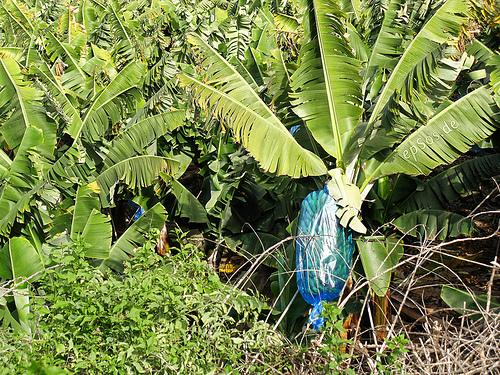Briefly mention the main elements found in the image. A blue bag with bananas, green leaves, brown tree trunks, and various undergrowth are present in the image. Mention the prominent object along with its color and location in the image. There is a blue bag filled with bananas hanging on a tree amidst green leaves and brown tree trunks. Describe the image with a focus on its environment. In a tropical jungle setting with vibrant green vegetation, a blue bag full of bananas can be seen hanging from a tree. Mention the different colors and elements found in the image. The image features green leaves, blue bags, brown tree trunks, and yellow spots, along with areas of undergrowth. Describe the overall setting of the image along with the primary object. The image displays a lush green jungle setting with a blue bag containing bananas hanging from a tree. Using descriptive language, paint a picture of the image. Amidst the verdant foliage and towering brown trunks, a cerulean bag bursting with bananas adorns the tree's broad branches. Provide a simple summary of what can be seen in the image. A blue bag with bananas is hanging on a tree among green leaves and brown tree trunks. What is the overarching atmosphere of the photo? The image exudes a tropical atmosphere, displaying a blue bag filled with bananas amid lush green foliage and trees. Provide a concise description of the most prominent features in the image. A blue bag hangs from a tree filled with bananas, surrounded by vibrant green leaves, brown tree trunks, and various undergrowth elements. Explain the main purpose of the blue object in the context of the image. A blue plastic bag is hanging from a tree, being used for holding bananas in the midst of a lush green environment. 